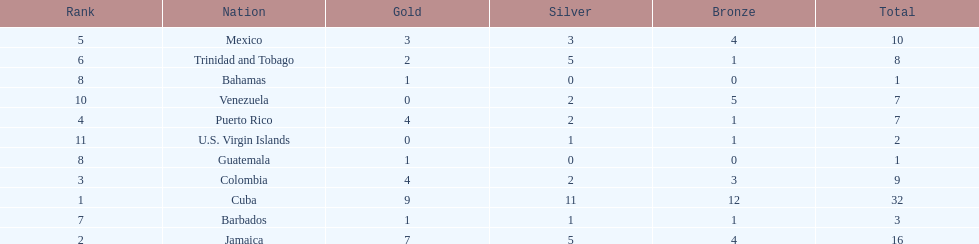Largest medal differential between countries 31. 